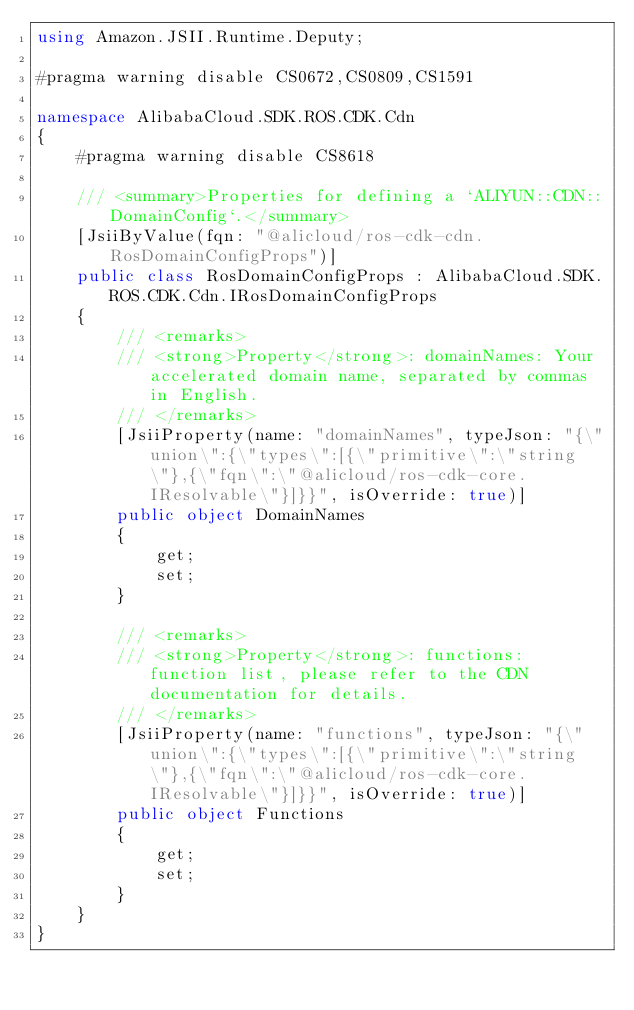Convert code to text. <code><loc_0><loc_0><loc_500><loc_500><_C#_>using Amazon.JSII.Runtime.Deputy;

#pragma warning disable CS0672,CS0809,CS1591

namespace AlibabaCloud.SDK.ROS.CDK.Cdn
{
    #pragma warning disable CS8618

    /// <summary>Properties for defining a `ALIYUN::CDN::DomainConfig`.</summary>
    [JsiiByValue(fqn: "@alicloud/ros-cdk-cdn.RosDomainConfigProps")]
    public class RosDomainConfigProps : AlibabaCloud.SDK.ROS.CDK.Cdn.IRosDomainConfigProps
    {
        /// <remarks>
        /// <strong>Property</strong>: domainNames: Your accelerated domain name, separated by commas in English.
        /// </remarks>
        [JsiiProperty(name: "domainNames", typeJson: "{\"union\":{\"types\":[{\"primitive\":\"string\"},{\"fqn\":\"@alicloud/ros-cdk-core.IResolvable\"}]}}", isOverride: true)]
        public object DomainNames
        {
            get;
            set;
        }

        /// <remarks>
        /// <strong>Property</strong>: functions: function list, please refer to the CDN documentation for details.
        /// </remarks>
        [JsiiProperty(name: "functions", typeJson: "{\"union\":{\"types\":[{\"primitive\":\"string\"},{\"fqn\":\"@alicloud/ros-cdk-core.IResolvable\"}]}}", isOverride: true)]
        public object Functions
        {
            get;
            set;
        }
    }
}
</code> 